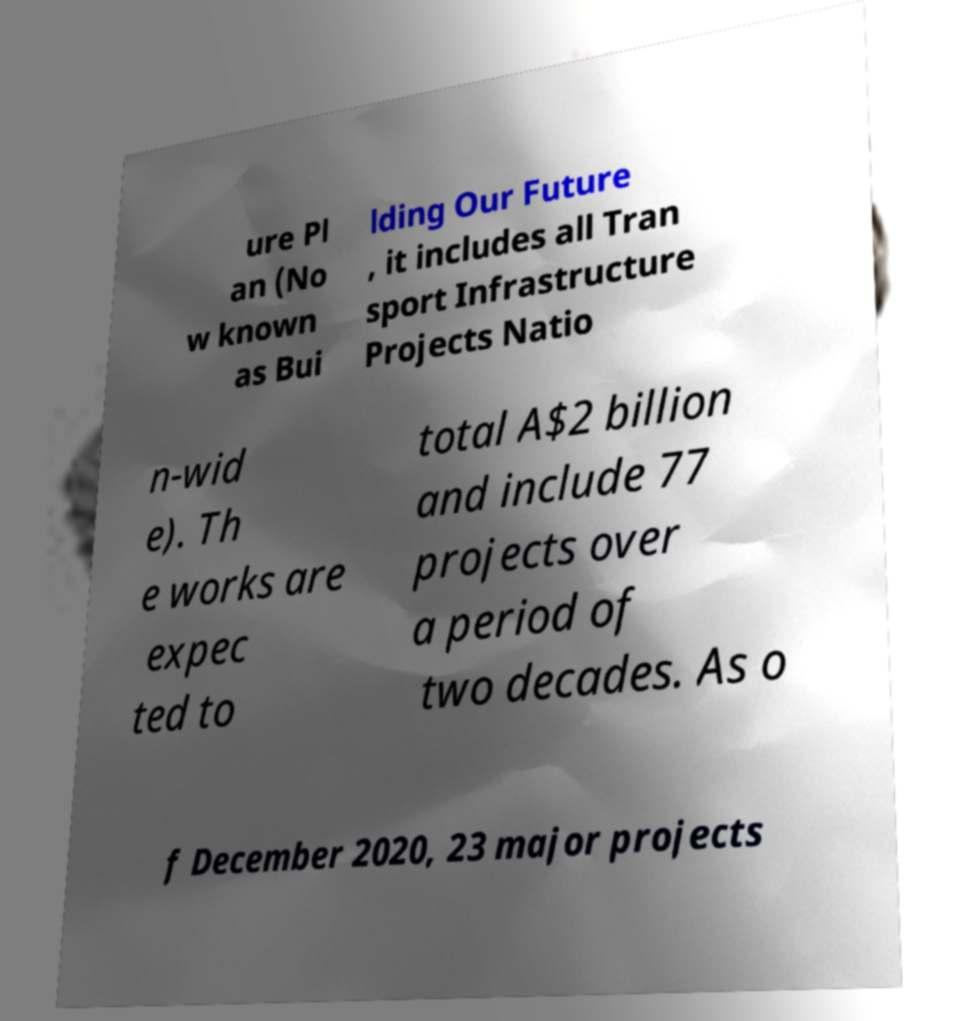What messages or text are displayed in this image? I need them in a readable, typed format. ure Pl an (No w known as Bui lding Our Future , it includes all Tran sport Infrastructure Projects Natio n-wid e). Th e works are expec ted to total A$2 billion and include 77 projects over a period of two decades. As o f December 2020, 23 major projects 